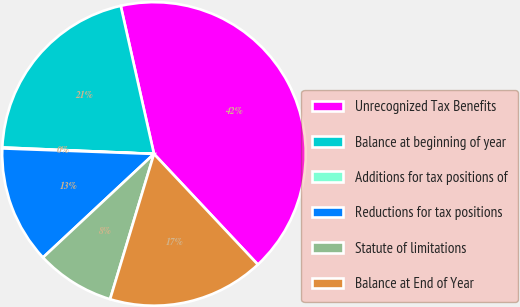Convert chart to OTSL. <chart><loc_0><loc_0><loc_500><loc_500><pie_chart><fcel>Unrecognized Tax Benefits<fcel>Balance at beginning of year<fcel>Additions for tax positions of<fcel>Reductions for tax positions<fcel>Statute of limitations<fcel>Balance at End of Year<nl><fcel>41.52%<fcel>20.81%<fcel>0.1%<fcel>12.53%<fcel>8.38%<fcel>16.67%<nl></chart> 